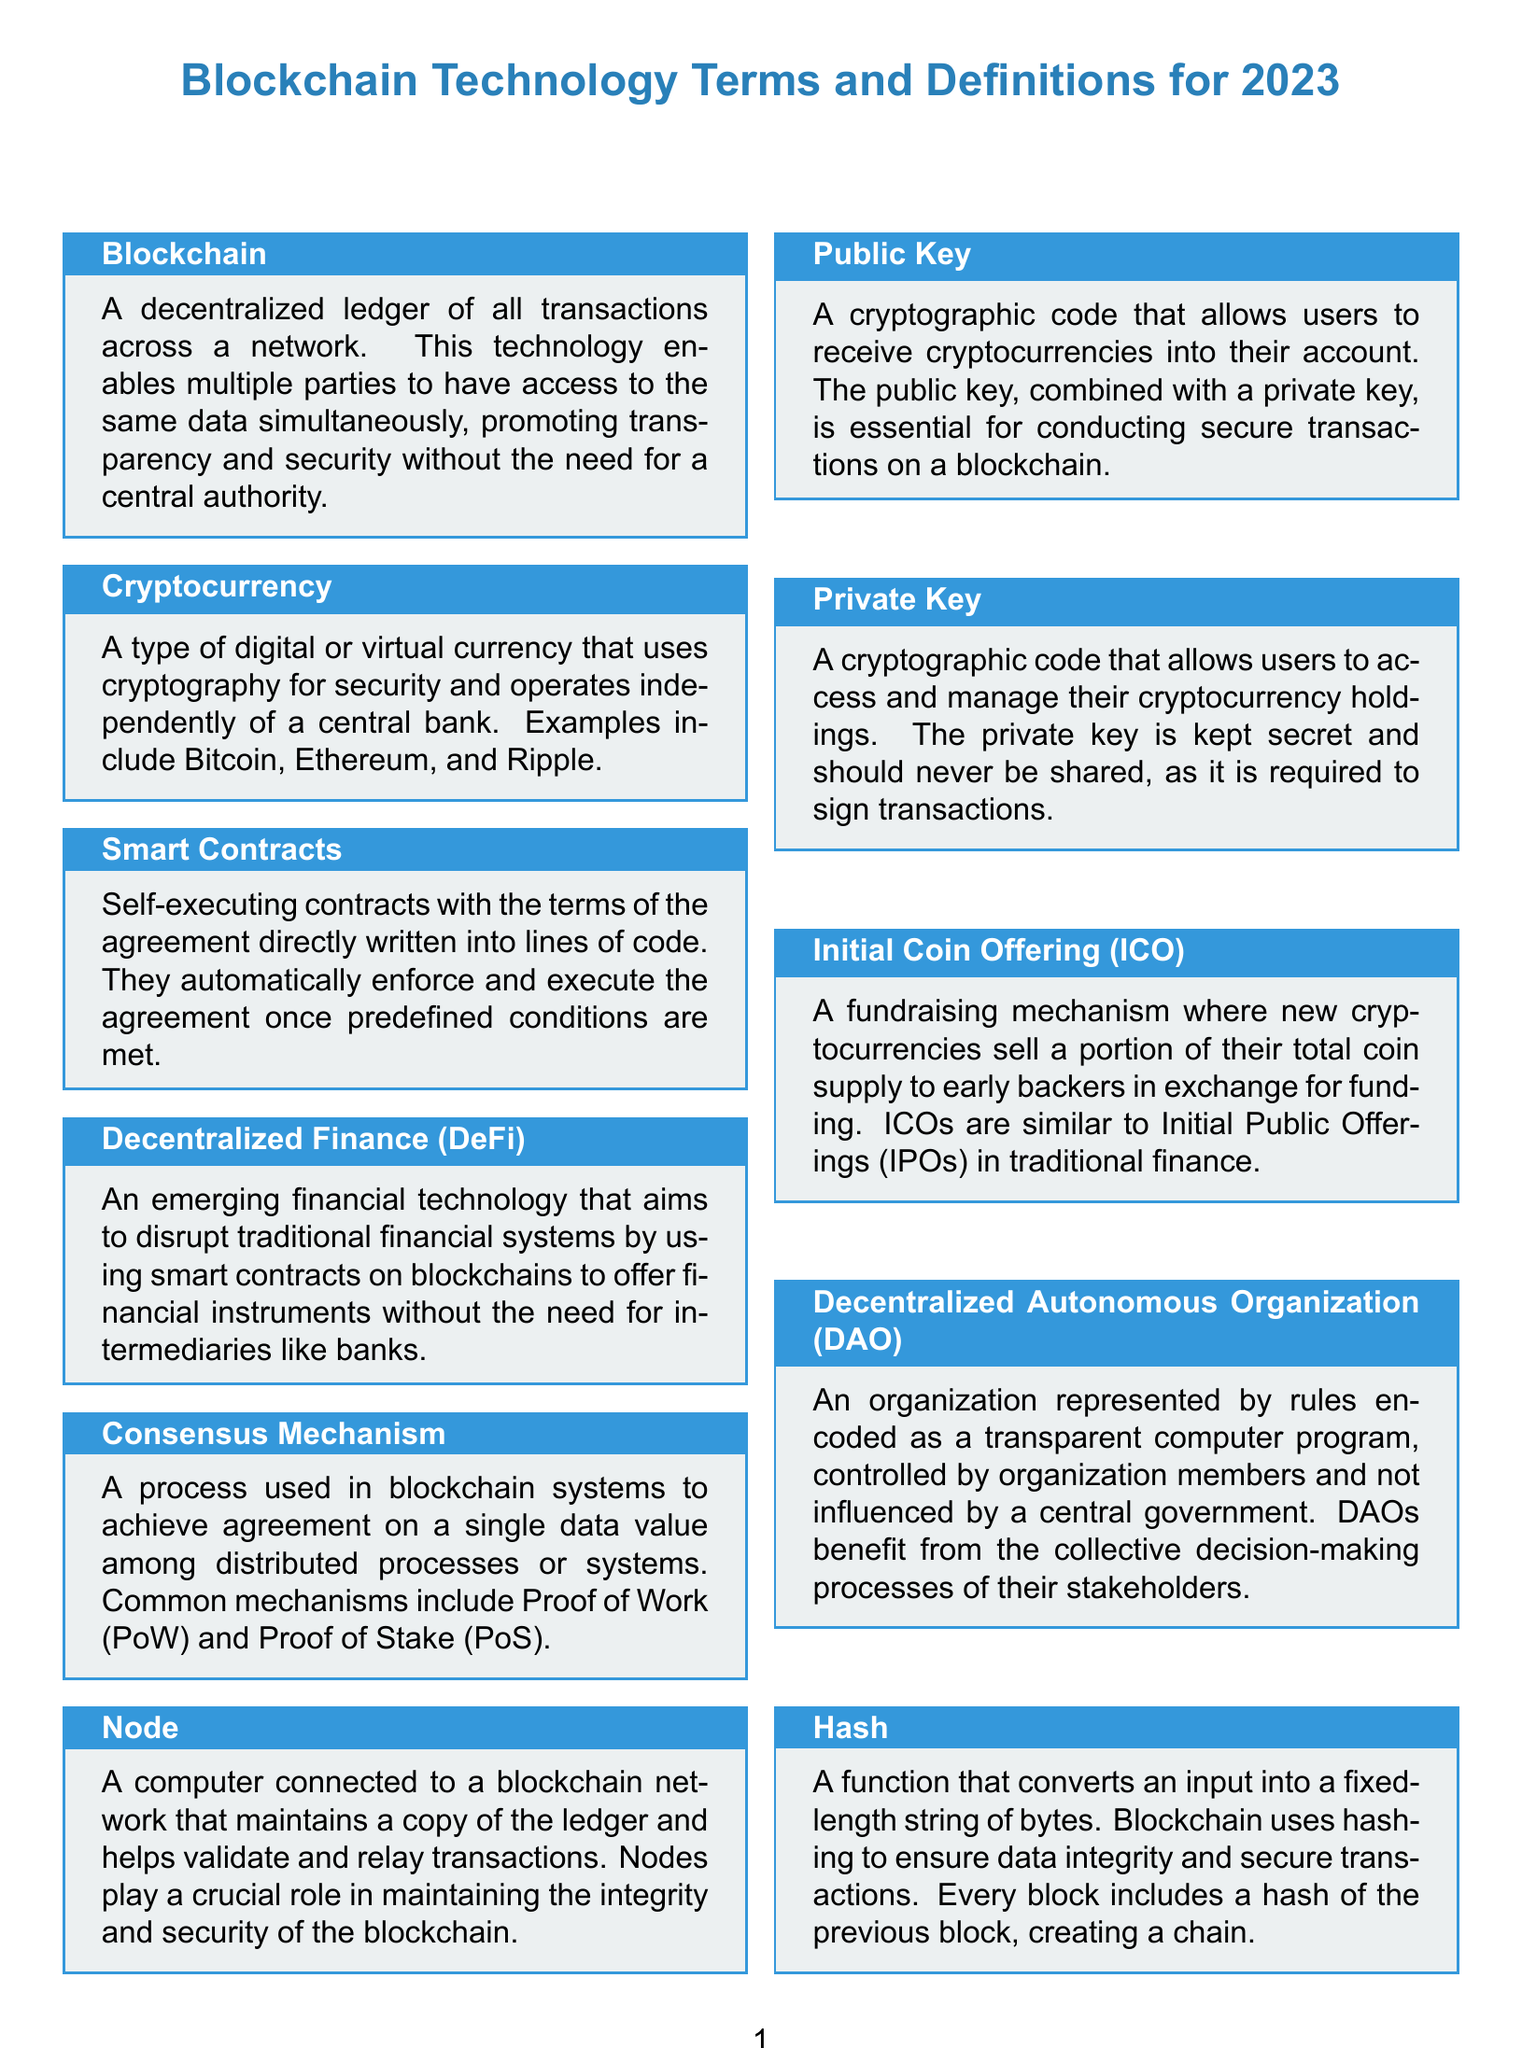What is a decentralized ledger? A decentralized ledger is defined in the document as a ledger of all transactions across a network.
Answer: A decentralized ledger What does ICO stand for? The abbreviation ICO refers to a fundraising mechanism mentioned in the document.
Answer: Initial Coin Offering What is the native cryptocurrency of Ethereum? The native cryptocurrency of Ethereum is specified in the document.
Answer: Ether What are two common consensus mechanisms? The document lists specific consensus mechanisms used in blockchain systems.
Answer: Proof of Work, Proof of Stake What is the purpose of a private key? The document explains the role of a private key in cryptocurrency transactions.
Answer: Access and manage cryptocurrency holdings How does a Smart Contract operate? The document describes the execution mechanism of a Smart Contract.
Answer: Automatically enforce and execute agreements Which organization type benefits from collective decision-making? The type of organization benefiting from collective decision-making is defined in the document.
Answer: Decentralized Autonomous Organization What technology records transactions in multiple places simultaneously? The technology used for recording transactions in multiple places at the same time is defined in the document.
Answer: Distributed Ledger Technology What is the main function of nodes in a blockchain? The document explains the crucial role of nodes in maintaining the blockchain.
Answer: Validate and relay transactions 